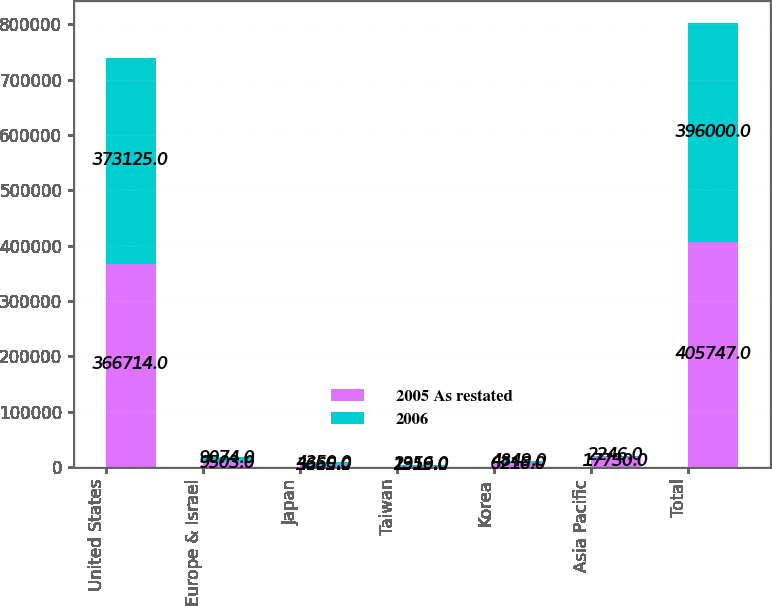<chart> <loc_0><loc_0><loc_500><loc_500><stacked_bar_chart><ecel><fcel>United States<fcel>Europe & Israel<fcel>Japan<fcel>Taiwan<fcel>Korea<fcel>Asia Pacific<fcel>Total<nl><fcel>2005 As restated<fcel>366714<fcel>9503<fcel>3665<fcel>1919<fcel>6216<fcel>17730<fcel>405747<nl><fcel>2006<fcel>373125<fcel>9074<fcel>4350<fcel>2356<fcel>4849<fcel>2246<fcel>396000<nl></chart> 